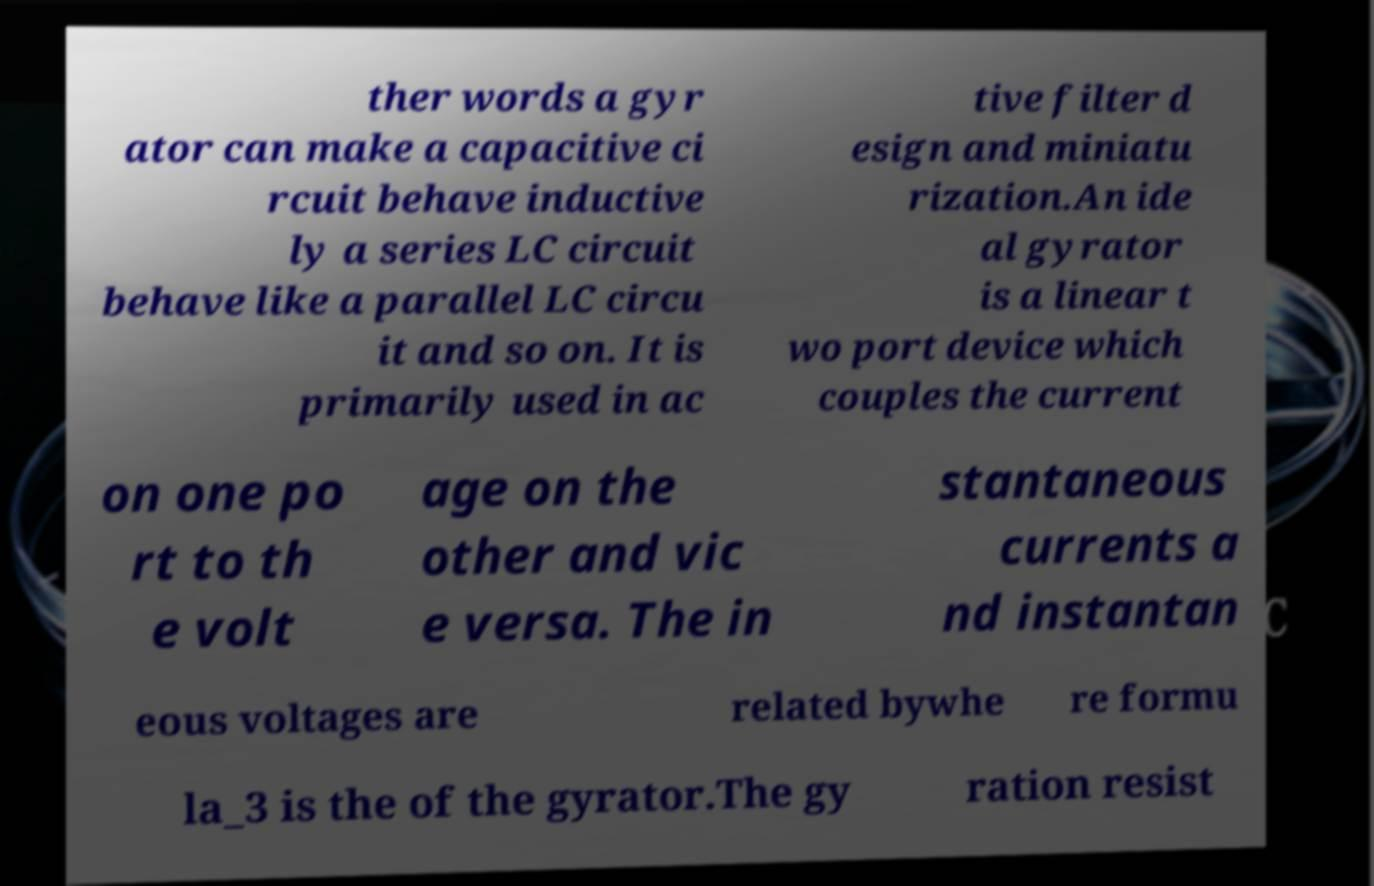For documentation purposes, I need the text within this image transcribed. Could you provide that? ther words a gyr ator can make a capacitive ci rcuit behave inductive ly a series LC circuit behave like a parallel LC circu it and so on. It is primarily used in ac tive filter d esign and miniatu rization.An ide al gyrator is a linear t wo port device which couples the current on one po rt to th e volt age on the other and vic e versa. The in stantaneous currents a nd instantan eous voltages are related bywhe re formu la_3 is the of the gyrator.The gy ration resist 